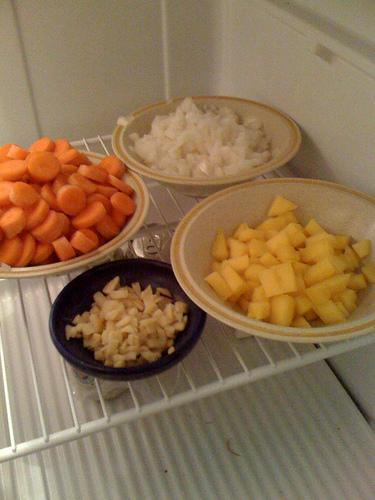Question: what are the color of the onions?
Choices:
A. Yellow.
B. White.
C. Red.
D. Green.
Answer with the letter. Answer: B Question: how many bowls are shown?
Choices:
A. 3.
B. 2.
C. 4.
D. 1.
Answer with the letter. Answer: C Question: what color are three of the bowls?
Choices:
A. Brown.
B. Tan.
C. Black.
D. White.
Answer with the letter. Answer: B Question: where are drinks?
Choices:
A. On bar.
B. On table.
C. Bottom shelf.
D. In hands.
Answer with the letter. Answer: C Question: what color are carrots?
Choices:
A. Brown.
B. Orange.
C. Black.
D. Red.
Answer with the letter. Answer: B 